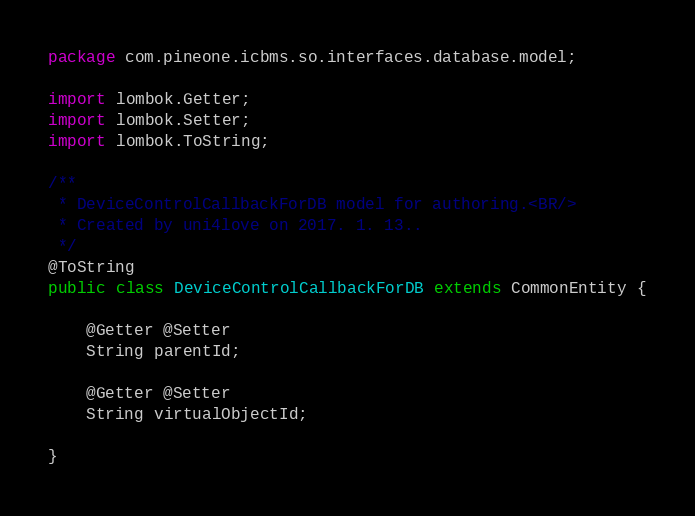Convert code to text. <code><loc_0><loc_0><loc_500><loc_500><_Java_>package com.pineone.icbms.so.interfaces.database.model;

import lombok.Getter;
import lombok.Setter;
import lombok.ToString;

/**
 * DeviceControlCallbackForDB model for authoring.<BR/>
 * Created by uni4love on 2017. 1. 13..
 */
@ToString
public class DeviceControlCallbackForDB extends CommonEntity {

    @Getter @Setter
    String parentId;

    @Getter @Setter
    String virtualObjectId;

}

</code> 